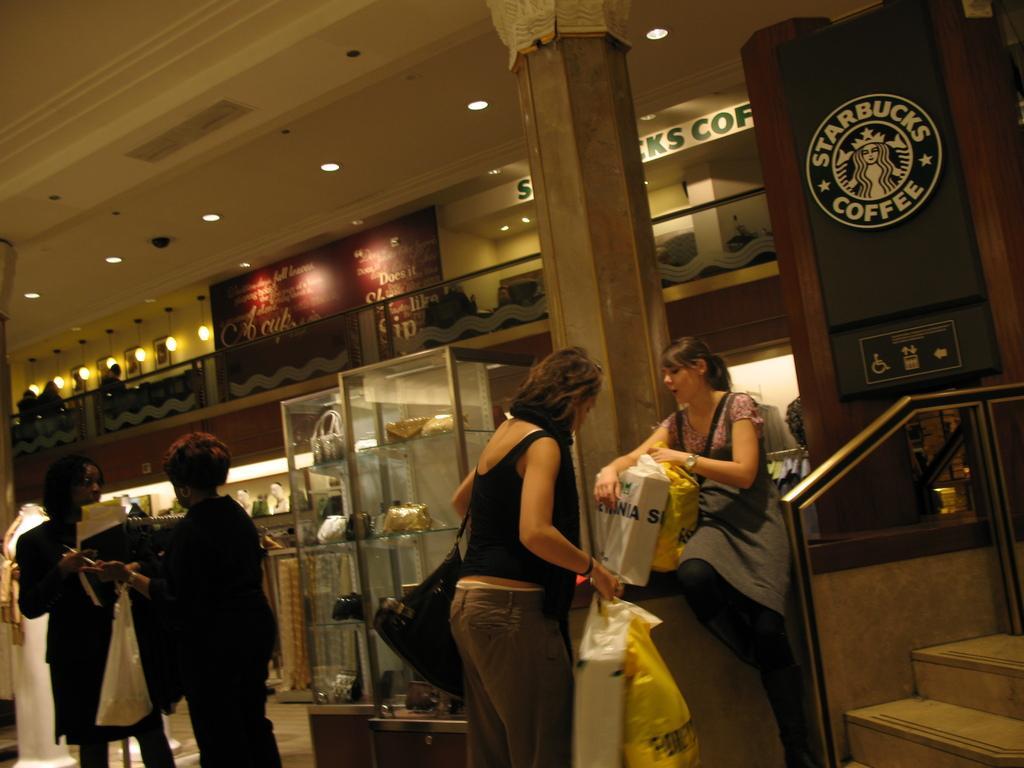Please provide a concise description of this image. In this picture we can see a group of people are standing and a woman is sitting. Behind the people there are some items and a pillar. There are ceiling lights on the top. 